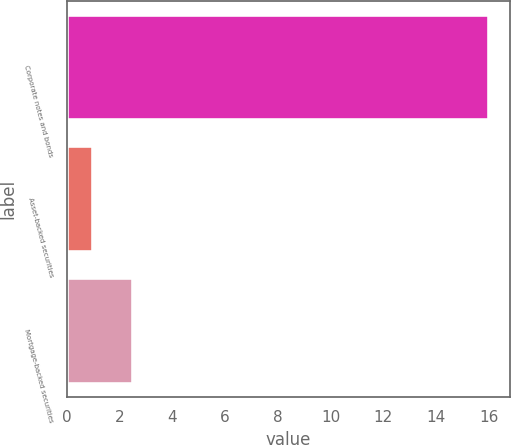Convert chart to OTSL. <chart><loc_0><loc_0><loc_500><loc_500><bar_chart><fcel>Corporate notes and bonds<fcel>Asset-backed securities<fcel>Mortgage-backed securities<nl><fcel>16<fcel>1<fcel>2.5<nl></chart> 